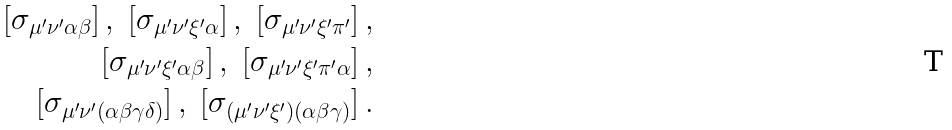<formula> <loc_0><loc_0><loc_500><loc_500>[ \sigma _ { \mu ^ { \prime } \nu ^ { \prime } \alpha \beta } ] \, , \ [ \sigma _ { \mu ^ { \prime } \nu ^ { \prime } \xi ^ { \prime } \alpha } ] \, , \ [ \sigma _ { \mu ^ { \prime } \nu ^ { \prime } \xi ^ { \prime } \pi ^ { \prime } } ] \, , \\ [ \sigma _ { \mu ^ { \prime } \nu ^ { \prime } \xi ^ { \prime } \alpha \beta } ] \, , \ [ \sigma _ { \mu ^ { \prime } \nu ^ { \prime } \xi ^ { \prime } \pi ^ { \prime } \alpha } ] \, , \\ [ \sigma _ { \mu ^ { \prime } \nu ^ { \prime } ( \alpha \beta \gamma \delta ) } ] \, , \ [ \sigma _ { ( \mu ^ { \prime } \nu ^ { \prime } \xi ^ { \prime } ) ( \alpha \beta \gamma ) } ] \, .</formula> 